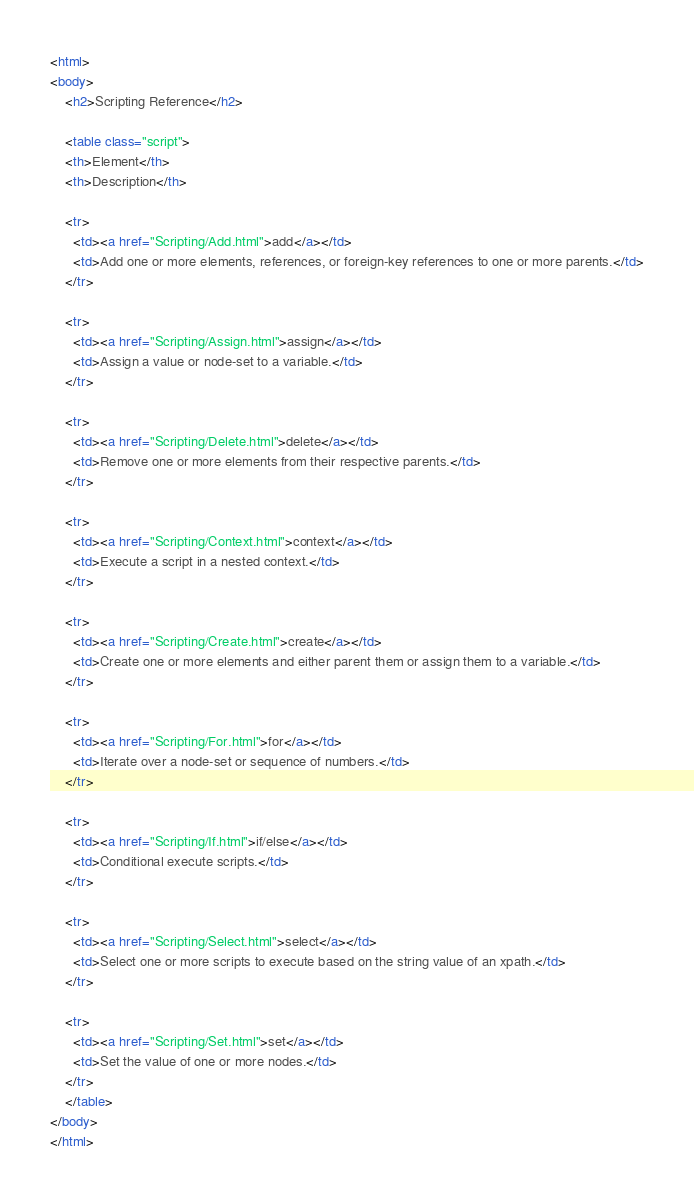Convert code to text. <code><loc_0><loc_0><loc_500><loc_500><_HTML_><html>
<body>
	<h2>Scripting Reference</h2>
	
	<table class="script">
	<th>Element</th>
	<th>Description</th>
	
	<tr>
	  <td><a href="Scripting/Add.html">add</a></td>
	  <td>Add one or more elements, references, or foreign-key references to one or more parents.</td>
	</tr>
	
	<tr>
	  <td><a href="Scripting/Assign.html">assign</a></td>
	  <td>Assign a value or node-set to a variable.</td>
	</tr>
	
	<tr>
	  <td><a href="Scripting/Delete.html">delete</a></td>
	  <td>Remove one or more elements from their respective parents.</td>
	</tr>
	
	<tr>
	  <td><a href="Scripting/Context.html">context</a></td>
	  <td>Execute a script in a nested context.</td>
	</tr>
	
	<tr>
	  <td><a href="Scripting/Create.html">create</a></td>
	  <td>Create one or more elements and either parent them or assign them to a variable.</td>
	</tr>
	
	<tr>
	  <td><a href="Scripting/For.html">for</a></td>
	  <td>Iterate over a node-set or sequence of numbers.</td>
	</tr>
	
	<tr>
	  <td><a href="Scripting/If.html">if/else</a></td>
	  <td>Conditional execute scripts.</td>
	</tr>
	
	<tr>
	  <td><a href="Scripting/Select.html">select</a></td>
	  <td>Select one or more scripts to execute based on the string value of an xpath.</td>
	</tr>
	
	<tr>
	  <td><a href="Scripting/Set.html">set</a></td>
	  <td>Set the value of one or more nodes.</td>
	</tr>
	</table>
</body>
</html>
</code> 